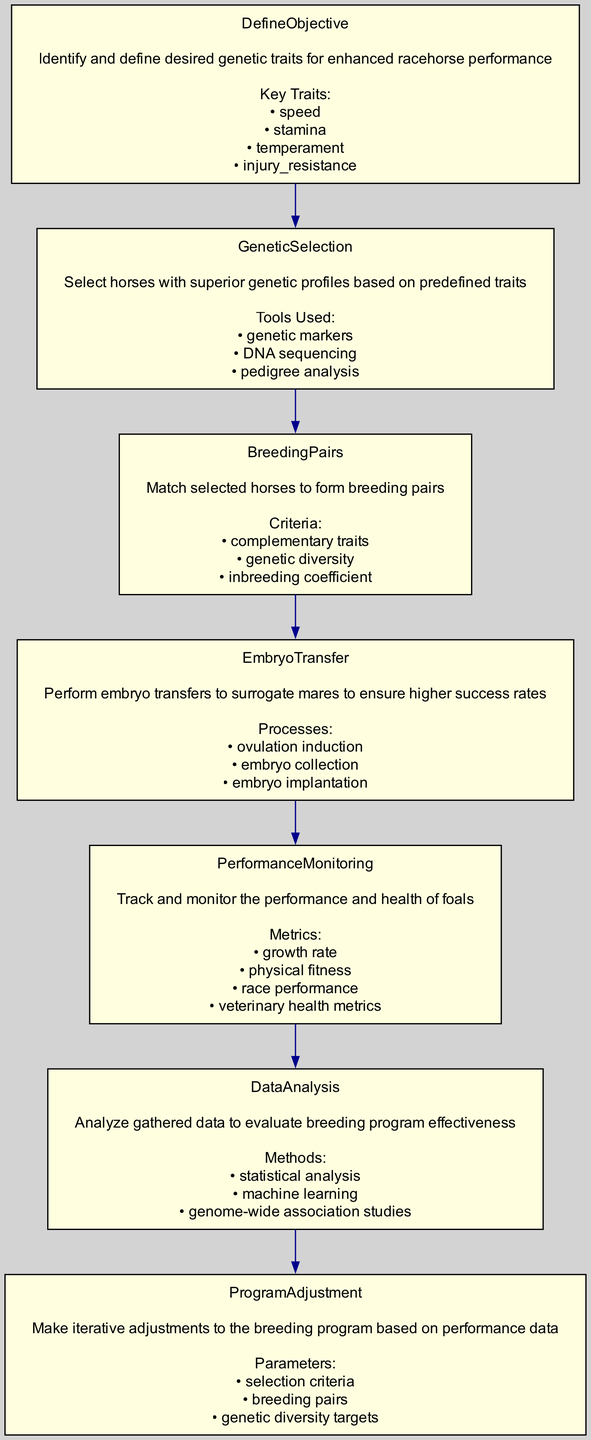What is the first step in the breeding program management? The first step is "DefineObjective", which identifies and defines desired genetic traits for enhanced racehorse performance. It sets the foundation for the rest of the process.
Answer: DefineObjective How many key traits are identified in the "DefineObjective" step? The "DefineObjective" step lists four key traits necessary for enhanced racehorse performance.
Answer: Four What tools are used in the "GeneticSelection" step? The tools used in "GeneticSelection" include genetic markers, DNA sequencing, and pedigree analysis. This indicates the methods chosen for selecting superior genetic profiles.
Answer: Genetic markers, DNA sequencing, pedigree analysis What is the process involved in "EmbryoTransfer"? The processes involved in "EmbryoTransfer" include ovulation induction, embryo collection, and embryo implantation. Each of these processes is crucial for ensuring a successful transfer to surrogate mares.
Answer: Ovulation induction, embryo collection, embryo implantation Which step prepares for iterations based on performance data? "ProgramAdjustment" is the step designed to make iterative adjustments to the breeding program based on data collected from previous steps. This reflects the adaptability of the program.
Answer: ProgramAdjustment What are the criteria for forming breeding pairs? The criteria for forming breeding pairs are complementary traits, genetic diversity, and inbreeding coefficient. These criteria ensure optimal pairing for breeding.
Answer: Complementary traits, genetic diversity, inbreeding coefficient Which step focuses on analyzing gathered data? The "DataAnalysis" step specifically focuses on analyzing the gathered data to evaluate the effectiveness of the breeding program, leveraging various analytical methods.
Answer: DataAnalysis How does "PerformanceMonitoring" relate to the breeding program? "PerformanceMonitoring" tracks and monitors the performance and health of foals, which is crucial for assessing the success and areas needing improvement in the breeding program.
Answer: PerformanceMonitoring What describes the relationship between "EmbryoTransfer" and "PerformanceMonitoring"? "EmbryoTransfer" precedes "PerformanceMonitoring" in the sequence, indicating that embryo transfers occur before monitoring the performance of the resulting foals.
Answer: Sequential relationship 